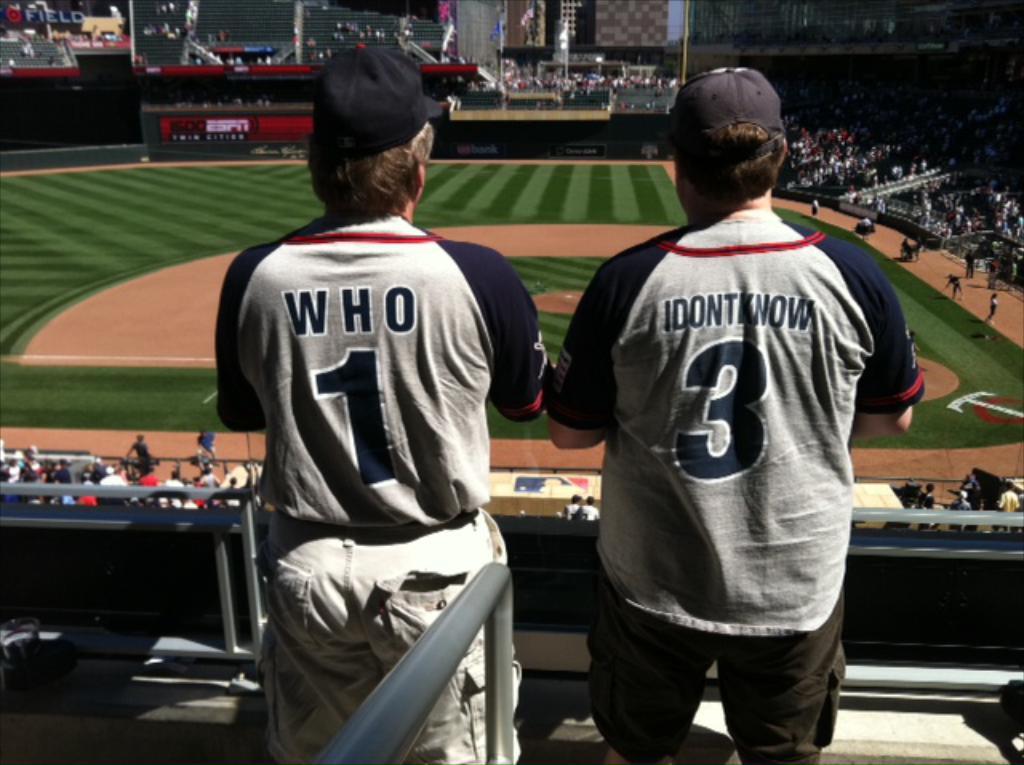What number is on who's jersey?
Provide a short and direct response. 1. What is the player name for jersey number 1?
Your answer should be compact. Who. 